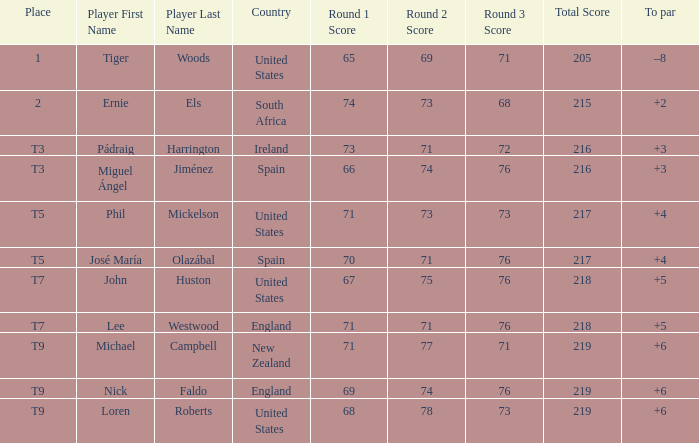What is Player, when Score is "66-74-76=216"? Miguel Ángel Jiménez. 